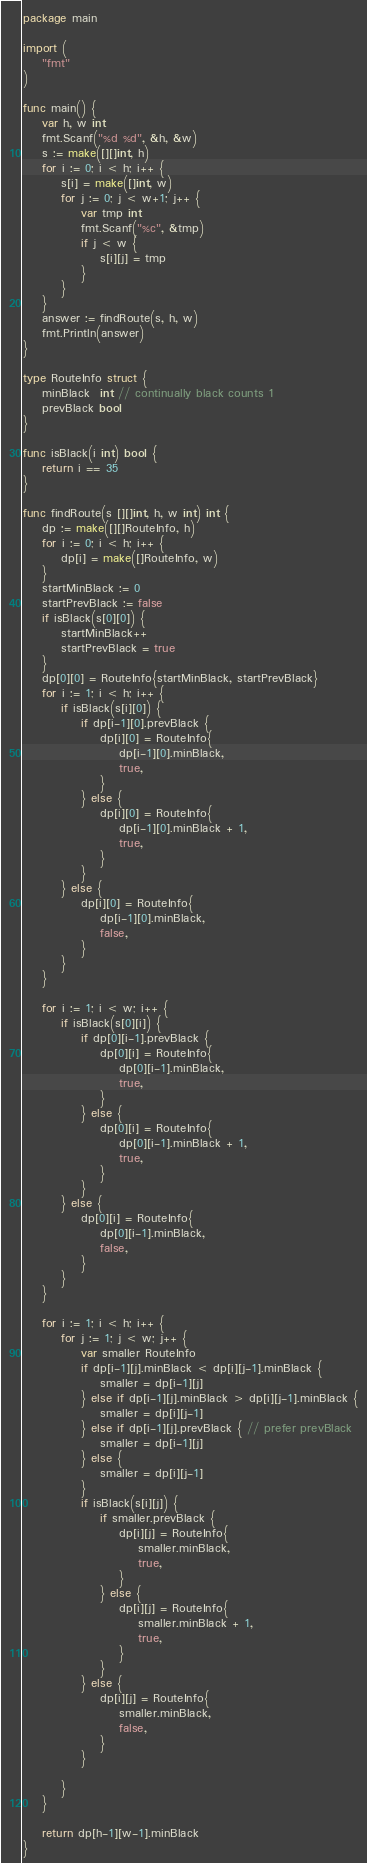Convert code to text. <code><loc_0><loc_0><loc_500><loc_500><_Go_>package main

import (
	"fmt"
)

func main() {
	var h, w int
	fmt.Scanf("%d %d", &h, &w)
	s := make([][]int, h)
	for i := 0; i < h; i++ {
		s[i] = make([]int, w)
		for j := 0; j < w+1; j++ {
			var tmp int
			fmt.Scanf("%c", &tmp)
			if j < w {
				s[i][j] = tmp
			}
		}
	}
	answer := findRoute(s, h, w)
	fmt.Println(answer)
}

type RouteInfo struct {
	minBlack  int // continually black counts 1
	prevBlack bool
}

func isBlack(i int) bool {
	return i == 35
}

func findRoute(s [][]int, h, w int) int {
	dp := make([][]RouteInfo, h)
	for i := 0; i < h; i++ {
		dp[i] = make([]RouteInfo, w)
	}
	startMinBlack := 0
	startPrevBlack := false
	if isBlack(s[0][0]) {
		startMinBlack++
		startPrevBlack = true
	}
	dp[0][0] = RouteInfo{startMinBlack, startPrevBlack}
	for i := 1; i < h; i++ {
		if isBlack(s[i][0]) {
			if dp[i-1][0].prevBlack {
				dp[i][0] = RouteInfo{
					dp[i-1][0].minBlack,
					true,
				}
			} else {
				dp[i][0] = RouteInfo{
					dp[i-1][0].minBlack + 1,
					true,
				}
			}
		} else {
			dp[i][0] = RouteInfo{
				dp[i-1][0].minBlack,
				false,
			}
		}
	}

	for i := 1; i < w; i++ {
		if isBlack(s[0][i]) {
			if dp[0][i-1].prevBlack {
				dp[0][i] = RouteInfo{
					dp[0][i-1].minBlack,
					true,
				}
			} else {
				dp[0][i] = RouteInfo{
					dp[0][i-1].minBlack + 1,
					true,
				}
			}
		} else {
			dp[0][i] = RouteInfo{
				dp[0][i-1].minBlack,
				false,
			}
		}
	}

	for i := 1; i < h; i++ {
		for j := 1; j < w; j++ {
			var smaller RouteInfo
			if dp[i-1][j].minBlack < dp[i][j-1].minBlack {
				smaller = dp[i-1][j]
			} else if dp[i-1][j].minBlack > dp[i][j-1].minBlack {
				smaller = dp[i][j-1]
			} else if dp[i-1][j].prevBlack { // prefer prevBlack
				smaller = dp[i-1][j]
			} else {
				smaller = dp[i][j-1]
			}
			if isBlack(s[i][j]) {
				if smaller.prevBlack {
					dp[i][j] = RouteInfo{
						smaller.minBlack,
						true,
					}
				} else {
					dp[i][j] = RouteInfo{
						smaller.minBlack + 1,
						true,
					}
				}
			} else {
				dp[i][j] = RouteInfo{
					smaller.minBlack,
					false,
				}
			}

		}
	}

	return dp[h-1][w-1].minBlack
}
</code> 